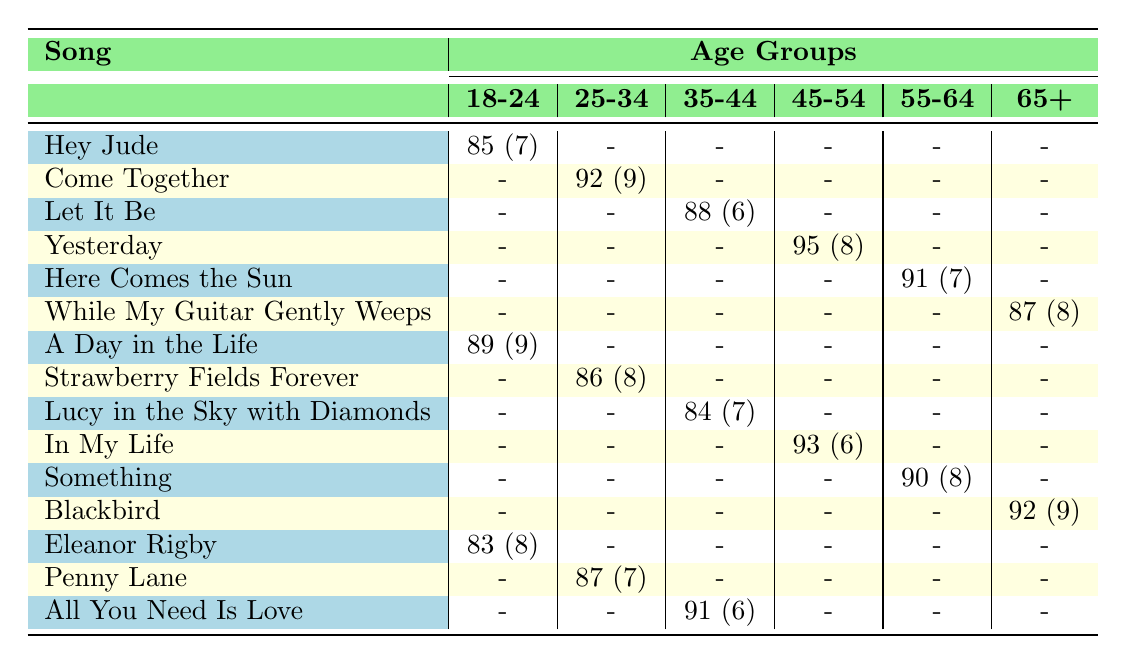What is the popularity score of "Come Together" in the 25-34 age group? The popularity score of "Come Together" in the 25-34 age group is listed directly in the table. It shows 92.
Answer: 92 Which song has the highest popularity score in the 45-54 age group? The table lists two songs in the 45-54 age group: "Yesterday" with a popularity score of 95 and "In My Life" with a score of 93. The highest is 95 for "Yesterday."
Answer: Yesterday What is the average jazz potential score for songs in the 65+ age group? The jazz potential scores for the 65+ age group are 8 from "While My Guitar Gently Weeps," and 9 from "Blackbird." The average is (8 + 9) / 2 = 8.5.
Answer: 8.5 Is "Hey Jude" popular among those aged 18-24, and what is its score? The table shows that "Hey Jude" has a popularity score of 85 in the 18-24 age group, which indicates it is popular.
Answer: Yes, 85 Which age group shows the highest popularity score for "All You Need Is Love"? According to the table, "All You Need Is Love" is present in the 35-44 age group with a popularity score of 91. No other age groups have this song. Thus, it is the highest in that group.
Answer: 35-44 What song has the lowest popularity score among college students aged 18-24? For the 18-24 age group, the songs listed are "Hey Jude" (85), "A Day in the Life" (89), and "Eleanor Rigby" (83). Among these, "Eleanor Rigby" has the lowest score of 83.
Answer: Eleanor Rigby How many songs have a popularity score above 90 in the 55-64 age group? The table shows that "Here Comes the Sun" has a score of 91, and "Something" has a score of 90. Therefore, only one song exceeds a score of 90.
Answer: 1 What is the popularity score difference between "Lucy in the Sky with Diamonds" and "Strawberry Fields Forever" in the 35-44 age group? "Lucy in the Sky with Diamonds" has a score of 84 and "Strawberry Fields Forever" is not present in the 35-44 age group but in the 25-34 group with a score of 86. The difference is 86 - 84 = 2.
Answer: 2 Which demographic contributed to the highest popularity score for any Beatles song? Among the ratings, "Yesterday" in the 45-54 age group has the highest score of 95, associated with the demographic "Gen X." Therefore, this demographic contributed the highest score.
Answer: Gen X 